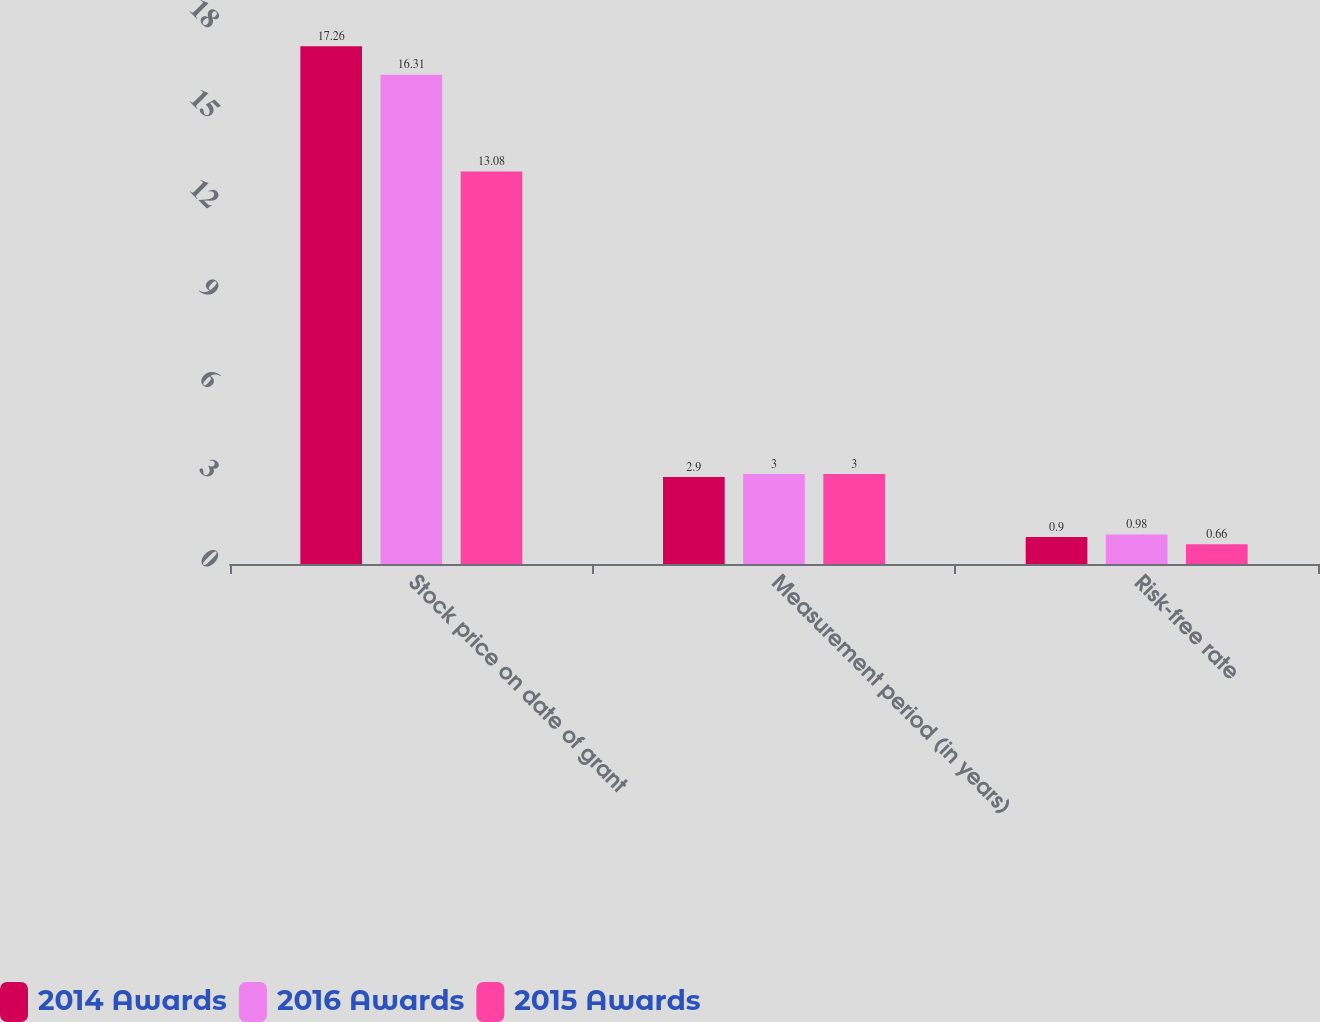Convert chart. <chart><loc_0><loc_0><loc_500><loc_500><stacked_bar_chart><ecel><fcel>Stock price on date of grant<fcel>Measurement period (in years)<fcel>Risk-free rate<nl><fcel>2014 Awards<fcel>17.26<fcel>2.9<fcel>0.9<nl><fcel>2016 Awards<fcel>16.31<fcel>3<fcel>0.98<nl><fcel>2015 Awards<fcel>13.08<fcel>3<fcel>0.66<nl></chart> 